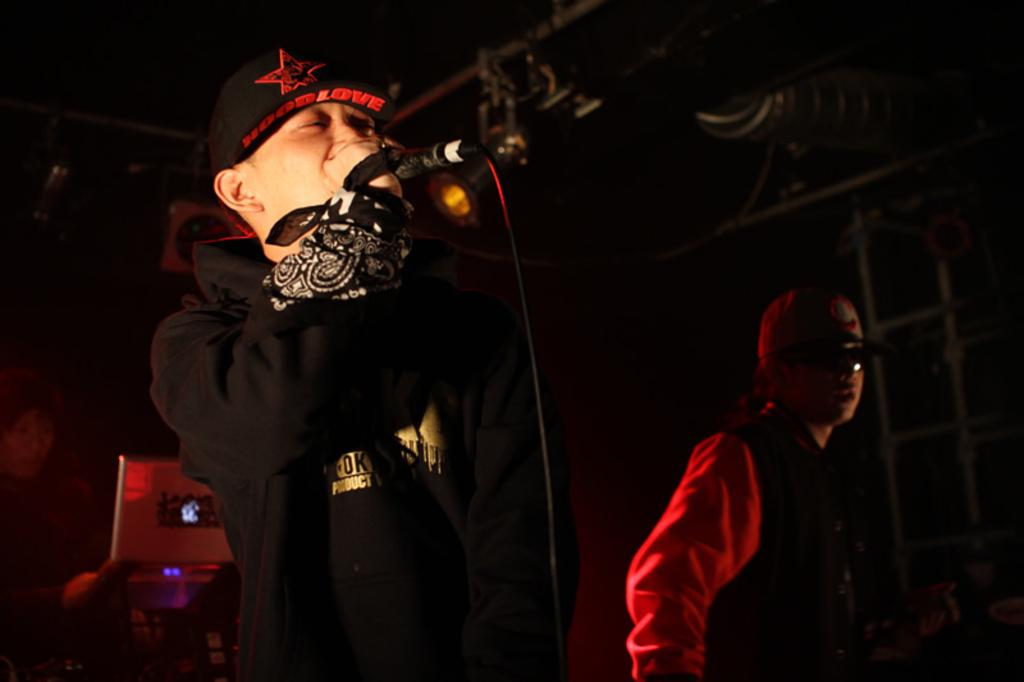How many people are in the image? There are two men in the image. What is one of the men doing in the image? One of the men is singing a song. Can you describe the setting where the man is singing? The man who is singing is in front of a microphone. What type of cannon is being fired at the border in the image? There is no cannon or border present in the image. How does the man start singing in the image? The image does not show the man starting to sing, so it cannot be determined from the image. 